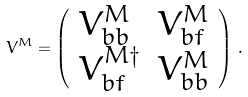<formula> <loc_0><loc_0><loc_500><loc_500>V ^ { M } = \left ( \begin{array} { l l } V _ { b b } ^ { M } & V _ { b f } ^ { M } \\ V _ { b f } ^ { M \dagger } & V _ { b b } ^ { M } \end{array} \right ) \, .</formula> 